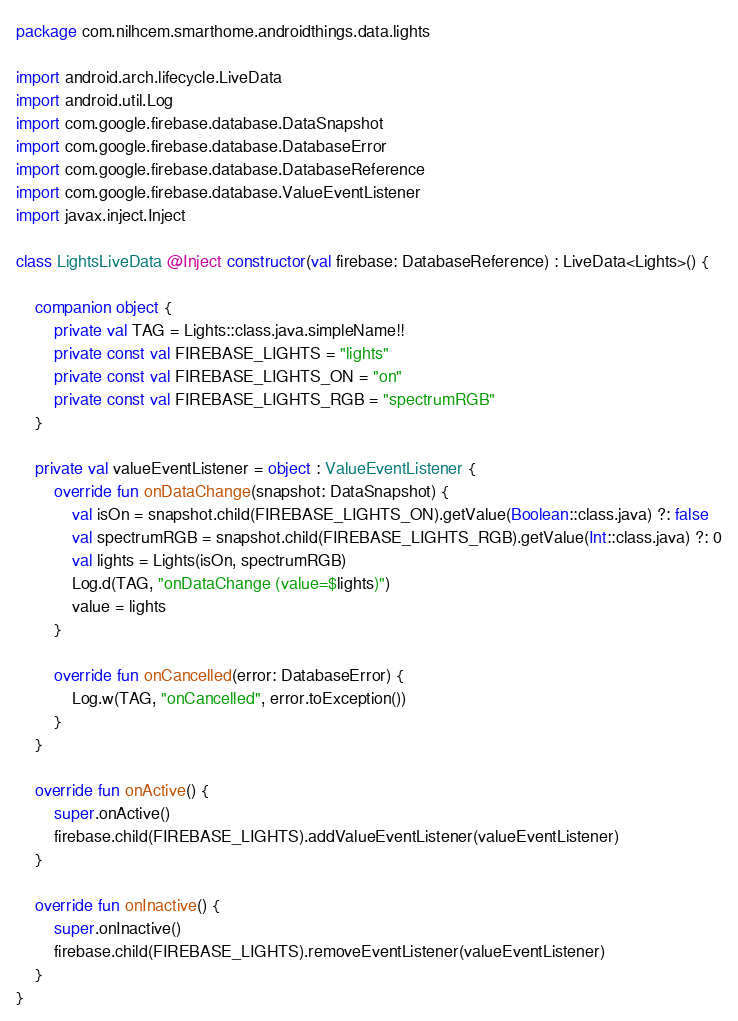Convert code to text. <code><loc_0><loc_0><loc_500><loc_500><_Kotlin_>package com.nilhcem.smarthome.androidthings.data.lights

import android.arch.lifecycle.LiveData
import android.util.Log
import com.google.firebase.database.DataSnapshot
import com.google.firebase.database.DatabaseError
import com.google.firebase.database.DatabaseReference
import com.google.firebase.database.ValueEventListener
import javax.inject.Inject

class LightsLiveData @Inject constructor(val firebase: DatabaseReference) : LiveData<Lights>() {

    companion object {
        private val TAG = Lights::class.java.simpleName!!
        private const val FIREBASE_LIGHTS = "lights"
        private const val FIREBASE_LIGHTS_ON = "on"
        private const val FIREBASE_LIGHTS_RGB = "spectrumRGB"
    }

    private val valueEventListener = object : ValueEventListener {
        override fun onDataChange(snapshot: DataSnapshot) {
            val isOn = snapshot.child(FIREBASE_LIGHTS_ON).getValue(Boolean::class.java) ?: false
            val spectrumRGB = snapshot.child(FIREBASE_LIGHTS_RGB).getValue(Int::class.java) ?: 0
            val lights = Lights(isOn, spectrumRGB)
            Log.d(TAG, "onDataChange (value=$lights)")
            value = lights
        }

        override fun onCancelled(error: DatabaseError) {
            Log.w(TAG, "onCancelled", error.toException())
        }
    }

    override fun onActive() {
        super.onActive()
        firebase.child(FIREBASE_LIGHTS).addValueEventListener(valueEventListener)
    }

    override fun onInactive() {
        super.onInactive()
        firebase.child(FIREBASE_LIGHTS).removeEventListener(valueEventListener)
    }
}
</code> 